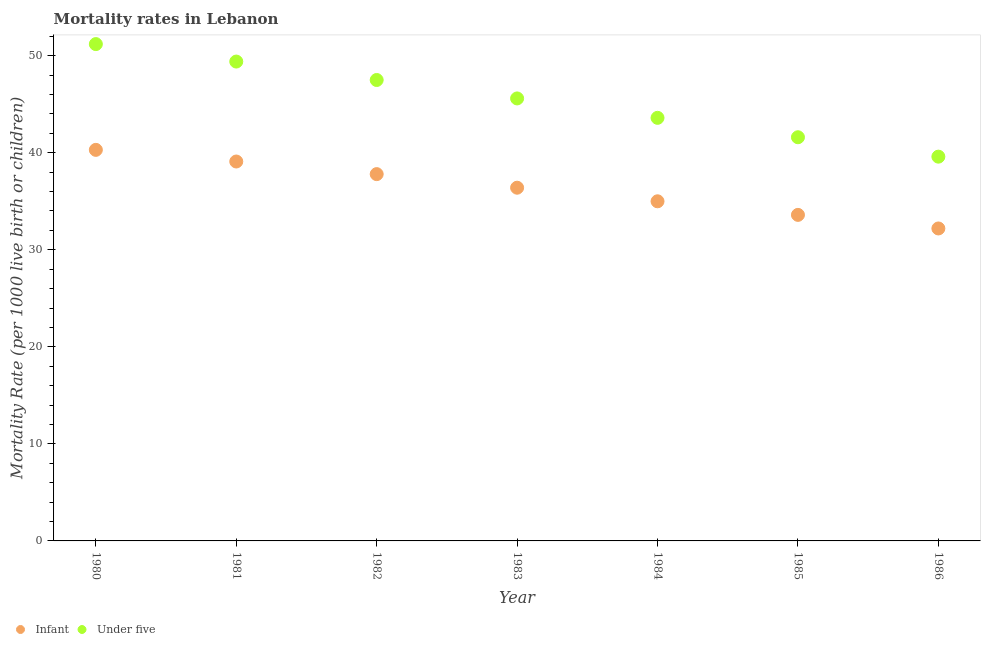How many different coloured dotlines are there?
Provide a succinct answer. 2. Is the number of dotlines equal to the number of legend labels?
Your answer should be very brief. Yes. What is the infant mortality rate in 1986?
Offer a terse response. 32.2. Across all years, what is the maximum under-5 mortality rate?
Ensure brevity in your answer.  51.2. Across all years, what is the minimum under-5 mortality rate?
Make the answer very short. 39.6. In which year was the infant mortality rate minimum?
Offer a very short reply. 1986. What is the total under-5 mortality rate in the graph?
Make the answer very short. 318.5. What is the difference between the under-5 mortality rate in 1981 and that in 1985?
Offer a very short reply. 7.8. What is the difference between the infant mortality rate in 1982 and the under-5 mortality rate in 1983?
Your answer should be compact. -7.8. What is the average under-5 mortality rate per year?
Give a very brief answer. 45.5. In the year 1981, what is the difference between the under-5 mortality rate and infant mortality rate?
Keep it short and to the point. 10.3. In how many years, is the infant mortality rate greater than 2?
Provide a short and direct response. 7. What is the ratio of the infant mortality rate in 1984 to that in 1985?
Keep it short and to the point. 1.04. Is the infant mortality rate in 1980 less than that in 1985?
Make the answer very short. No. What is the difference between the highest and the second highest infant mortality rate?
Give a very brief answer. 1.2. What is the difference between the highest and the lowest under-5 mortality rate?
Ensure brevity in your answer.  11.6. In how many years, is the under-5 mortality rate greater than the average under-5 mortality rate taken over all years?
Keep it short and to the point. 4. Does the infant mortality rate monotonically increase over the years?
Give a very brief answer. No. Is the under-5 mortality rate strictly less than the infant mortality rate over the years?
Offer a terse response. No. How many years are there in the graph?
Give a very brief answer. 7. What is the difference between two consecutive major ticks on the Y-axis?
Provide a succinct answer. 10. Are the values on the major ticks of Y-axis written in scientific E-notation?
Give a very brief answer. No. Does the graph contain any zero values?
Your answer should be very brief. No. Does the graph contain grids?
Your response must be concise. No. What is the title of the graph?
Provide a short and direct response. Mortality rates in Lebanon. Does "Measles" appear as one of the legend labels in the graph?
Provide a short and direct response. No. What is the label or title of the X-axis?
Offer a terse response. Year. What is the label or title of the Y-axis?
Ensure brevity in your answer.  Mortality Rate (per 1000 live birth or children). What is the Mortality Rate (per 1000 live birth or children) of Infant in 1980?
Provide a succinct answer. 40.3. What is the Mortality Rate (per 1000 live birth or children) of Under five in 1980?
Your response must be concise. 51.2. What is the Mortality Rate (per 1000 live birth or children) in Infant in 1981?
Your response must be concise. 39.1. What is the Mortality Rate (per 1000 live birth or children) in Under five in 1981?
Ensure brevity in your answer.  49.4. What is the Mortality Rate (per 1000 live birth or children) in Infant in 1982?
Your response must be concise. 37.8. What is the Mortality Rate (per 1000 live birth or children) of Under five in 1982?
Offer a terse response. 47.5. What is the Mortality Rate (per 1000 live birth or children) of Infant in 1983?
Your answer should be very brief. 36.4. What is the Mortality Rate (per 1000 live birth or children) of Under five in 1983?
Provide a succinct answer. 45.6. What is the Mortality Rate (per 1000 live birth or children) in Infant in 1984?
Provide a succinct answer. 35. What is the Mortality Rate (per 1000 live birth or children) in Under five in 1984?
Your response must be concise. 43.6. What is the Mortality Rate (per 1000 live birth or children) in Infant in 1985?
Provide a short and direct response. 33.6. What is the Mortality Rate (per 1000 live birth or children) in Under five in 1985?
Provide a short and direct response. 41.6. What is the Mortality Rate (per 1000 live birth or children) of Infant in 1986?
Offer a terse response. 32.2. What is the Mortality Rate (per 1000 live birth or children) in Under five in 1986?
Your answer should be very brief. 39.6. Across all years, what is the maximum Mortality Rate (per 1000 live birth or children) of Infant?
Offer a very short reply. 40.3. Across all years, what is the maximum Mortality Rate (per 1000 live birth or children) of Under five?
Your response must be concise. 51.2. Across all years, what is the minimum Mortality Rate (per 1000 live birth or children) in Infant?
Your answer should be compact. 32.2. Across all years, what is the minimum Mortality Rate (per 1000 live birth or children) of Under five?
Your answer should be compact. 39.6. What is the total Mortality Rate (per 1000 live birth or children) of Infant in the graph?
Ensure brevity in your answer.  254.4. What is the total Mortality Rate (per 1000 live birth or children) of Under five in the graph?
Your answer should be compact. 318.5. What is the difference between the Mortality Rate (per 1000 live birth or children) of Under five in 1980 and that in 1981?
Ensure brevity in your answer.  1.8. What is the difference between the Mortality Rate (per 1000 live birth or children) of Under five in 1980 and that in 1983?
Offer a very short reply. 5.6. What is the difference between the Mortality Rate (per 1000 live birth or children) of Under five in 1980 and that in 1984?
Make the answer very short. 7.6. What is the difference between the Mortality Rate (per 1000 live birth or children) of Under five in 1980 and that in 1985?
Your response must be concise. 9.6. What is the difference between the Mortality Rate (per 1000 live birth or children) of Infant in 1981 and that in 1982?
Provide a short and direct response. 1.3. What is the difference between the Mortality Rate (per 1000 live birth or children) of Under five in 1981 and that in 1982?
Make the answer very short. 1.9. What is the difference between the Mortality Rate (per 1000 live birth or children) of Infant in 1981 and that in 1983?
Your answer should be very brief. 2.7. What is the difference between the Mortality Rate (per 1000 live birth or children) in Under five in 1981 and that in 1984?
Keep it short and to the point. 5.8. What is the difference between the Mortality Rate (per 1000 live birth or children) of Infant in 1982 and that in 1984?
Your answer should be very brief. 2.8. What is the difference between the Mortality Rate (per 1000 live birth or children) of Infant in 1982 and that in 1985?
Provide a short and direct response. 4.2. What is the difference between the Mortality Rate (per 1000 live birth or children) of Under five in 1983 and that in 1984?
Offer a very short reply. 2. What is the difference between the Mortality Rate (per 1000 live birth or children) of Infant in 1983 and that in 1985?
Provide a short and direct response. 2.8. What is the difference between the Mortality Rate (per 1000 live birth or children) in Under five in 1983 and that in 1985?
Provide a succinct answer. 4. What is the difference between the Mortality Rate (per 1000 live birth or children) in Under five in 1983 and that in 1986?
Keep it short and to the point. 6. What is the difference between the Mortality Rate (per 1000 live birth or children) of Under five in 1984 and that in 1985?
Offer a terse response. 2. What is the difference between the Mortality Rate (per 1000 live birth or children) of Infant in 1985 and that in 1986?
Your answer should be very brief. 1.4. What is the difference between the Mortality Rate (per 1000 live birth or children) in Under five in 1985 and that in 1986?
Give a very brief answer. 2. What is the difference between the Mortality Rate (per 1000 live birth or children) in Infant in 1980 and the Mortality Rate (per 1000 live birth or children) in Under five in 1981?
Your answer should be very brief. -9.1. What is the difference between the Mortality Rate (per 1000 live birth or children) of Infant in 1980 and the Mortality Rate (per 1000 live birth or children) of Under five in 1984?
Provide a short and direct response. -3.3. What is the difference between the Mortality Rate (per 1000 live birth or children) of Infant in 1980 and the Mortality Rate (per 1000 live birth or children) of Under five in 1985?
Your answer should be compact. -1.3. What is the difference between the Mortality Rate (per 1000 live birth or children) in Infant in 1981 and the Mortality Rate (per 1000 live birth or children) in Under five in 1982?
Provide a succinct answer. -8.4. What is the difference between the Mortality Rate (per 1000 live birth or children) of Infant in 1981 and the Mortality Rate (per 1000 live birth or children) of Under five in 1985?
Your answer should be very brief. -2.5. What is the difference between the Mortality Rate (per 1000 live birth or children) in Infant in 1981 and the Mortality Rate (per 1000 live birth or children) in Under five in 1986?
Ensure brevity in your answer.  -0.5. What is the difference between the Mortality Rate (per 1000 live birth or children) in Infant in 1982 and the Mortality Rate (per 1000 live birth or children) in Under five in 1983?
Give a very brief answer. -7.8. What is the difference between the Mortality Rate (per 1000 live birth or children) in Infant in 1982 and the Mortality Rate (per 1000 live birth or children) in Under five in 1984?
Offer a very short reply. -5.8. What is the difference between the Mortality Rate (per 1000 live birth or children) in Infant in 1983 and the Mortality Rate (per 1000 live birth or children) in Under five in 1985?
Your answer should be very brief. -5.2. What is the difference between the Mortality Rate (per 1000 live birth or children) in Infant in 1983 and the Mortality Rate (per 1000 live birth or children) in Under five in 1986?
Offer a terse response. -3.2. What is the difference between the Mortality Rate (per 1000 live birth or children) in Infant in 1984 and the Mortality Rate (per 1000 live birth or children) in Under five in 1985?
Offer a very short reply. -6.6. What is the difference between the Mortality Rate (per 1000 live birth or children) of Infant in 1985 and the Mortality Rate (per 1000 live birth or children) of Under five in 1986?
Your answer should be very brief. -6. What is the average Mortality Rate (per 1000 live birth or children) of Infant per year?
Give a very brief answer. 36.34. What is the average Mortality Rate (per 1000 live birth or children) in Under five per year?
Offer a very short reply. 45.5. In the year 1982, what is the difference between the Mortality Rate (per 1000 live birth or children) of Infant and Mortality Rate (per 1000 live birth or children) of Under five?
Your response must be concise. -9.7. In the year 1983, what is the difference between the Mortality Rate (per 1000 live birth or children) in Infant and Mortality Rate (per 1000 live birth or children) in Under five?
Offer a terse response. -9.2. In the year 1984, what is the difference between the Mortality Rate (per 1000 live birth or children) in Infant and Mortality Rate (per 1000 live birth or children) in Under five?
Offer a very short reply. -8.6. What is the ratio of the Mortality Rate (per 1000 live birth or children) in Infant in 1980 to that in 1981?
Provide a succinct answer. 1.03. What is the ratio of the Mortality Rate (per 1000 live birth or children) of Under five in 1980 to that in 1981?
Give a very brief answer. 1.04. What is the ratio of the Mortality Rate (per 1000 live birth or children) in Infant in 1980 to that in 1982?
Make the answer very short. 1.07. What is the ratio of the Mortality Rate (per 1000 live birth or children) of Under five in 1980 to that in 1982?
Your response must be concise. 1.08. What is the ratio of the Mortality Rate (per 1000 live birth or children) in Infant in 1980 to that in 1983?
Ensure brevity in your answer.  1.11. What is the ratio of the Mortality Rate (per 1000 live birth or children) of Under five in 1980 to that in 1983?
Your answer should be very brief. 1.12. What is the ratio of the Mortality Rate (per 1000 live birth or children) of Infant in 1980 to that in 1984?
Your answer should be very brief. 1.15. What is the ratio of the Mortality Rate (per 1000 live birth or children) of Under five in 1980 to that in 1984?
Offer a terse response. 1.17. What is the ratio of the Mortality Rate (per 1000 live birth or children) in Infant in 1980 to that in 1985?
Your answer should be compact. 1.2. What is the ratio of the Mortality Rate (per 1000 live birth or children) in Under five in 1980 to that in 1985?
Ensure brevity in your answer.  1.23. What is the ratio of the Mortality Rate (per 1000 live birth or children) of Infant in 1980 to that in 1986?
Offer a very short reply. 1.25. What is the ratio of the Mortality Rate (per 1000 live birth or children) of Under five in 1980 to that in 1986?
Make the answer very short. 1.29. What is the ratio of the Mortality Rate (per 1000 live birth or children) of Infant in 1981 to that in 1982?
Offer a very short reply. 1.03. What is the ratio of the Mortality Rate (per 1000 live birth or children) of Under five in 1981 to that in 1982?
Provide a short and direct response. 1.04. What is the ratio of the Mortality Rate (per 1000 live birth or children) of Infant in 1981 to that in 1983?
Your answer should be very brief. 1.07. What is the ratio of the Mortality Rate (per 1000 live birth or children) in Under five in 1981 to that in 1983?
Give a very brief answer. 1.08. What is the ratio of the Mortality Rate (per 1000 live birth or children) of Infant in 1981 to that in 1984?
Give a very brief answer. 1.12. What is the ratio of the Mortality Rate (per 1000 live birth or children) of Under five in 1981 to that in 1984?
Ensure brevity in your answer.  1.13. What is the ratio of the Mortality Rate (per 1000 live birth or children) of Infant in 1981 to that in 1985?
Ensure brevity in your answer.  1.16. What is the ratio of the Mortality Rate (per 1000 live birth or children) of Under five in 1981 to that in 1985?
Your answer should be compact. 1.19. What is the ratio of the Mortality Rate (per 1000 live birth or children) in Infant in 1981 to that in 1986?
Offer a very short reply. 1.21. What is the ratio of the Mortality Rate (per 1000 live birth or children) of Under five in 1981 to that in 1986?
Provide a short and direct response. 1.25. What is the ratio of the Mortality Rate (per 1000 live birth or children) in Infant in 1982 to that in 1983?
Your answer should be very brief. 1.04. What is the ratio of the Mortality Rate (per 1000 live birth or children) of Under five in 1982 to that in 1983?
Your answer should be compact. 1.04. What is the ratio of the Mortality Rate (per 1000 live birth or children) of Infant in 1982 to that in 1984?
Ensure brevity in your answer.  1.08. What is the ratio of the Mortality Rate (per 1000 live birth or children) of Under five in 1982 to that in 1984?
Make the answer very short. 1.09. What is the ratio of the Mortality Rate (per 1000 live birth or children) of Under five in 1982 to that in 1985?
Your response must be concise. 1.14. What is the ratio of the Mortality Rate (per 1000 live birth or children) in Infant in 1982 to that in 1986?
Give a very brief answer. 1.17. What is the ratio of the Mortality Rate (per 1000 live birth or children) of Under five in 1982 to that in 1986?
Provide a short and direct response. 1.2. What is the ratio of the Mortality Rate (per 1000 live birth or children) of Under five in 1983 to that in 1984?
Provide a short and direct response. 1.05. What is the ratio of the Mortality Rate (per 1000 live birth or children) of Infant in 1983 to that in 1985?
Offer a very short reply. 1.08. What is the ratio of the Mortality Rate (per 1000 live birth or children) of Under five in 1983 to that in 1985?
Your answer should be very brief. 1.1. What is the ratio of the Mortality Rate (per 1000 live birth or children) of Infant in 1983 to that in 1986?
Your response must be concise. 1.13. What is the ratio of the Mortality Rate (per 1000 live birth or children) in Under five in 1983 to that in 1986?
Offer a terse response. 1.15. What is the ratio of the Mortality Rate (per 1000 live birth or children) of Infant in 1984 to that in 1985?
Provide a succinct answer. 1.04. What is the ratio of the Mortality Rate (per 1000 live birth or children) of Under five in 1984 to that in 1985?
Your response must be concise. 1.05. What is the ratio of the Mortality Rate (per 1000 live birth or children) in Infant in 1984 to that in 1986?
Provide a short and direct response. 1.09. What is the ratio of the Mortality Rate (per 1000 live birth or children) of Under five in 1984 to that in 1986?
Keep it short and to the point. 1.1. What is the ratio of the Mortality Rate (per 1000 live birth or children) in Infant in 1985 to that in 1986?
Offer a very short reply. 1.04. What is the ratio of the Mortality Rate (per 1000 live birth or children) in Under five in 1985 to that in 1986?
Offer a very short reply. 1.05. What is the difference between the highest and the second highest Mortality Rate (per 1000 live birth or children) in Infant?
Ensure brevity in your answer.  1.2. What is the difference between the highest and the second highest Mortality Rate (per 1000 live birth or children) in Under five?
Your response must be concise. 1.8. 